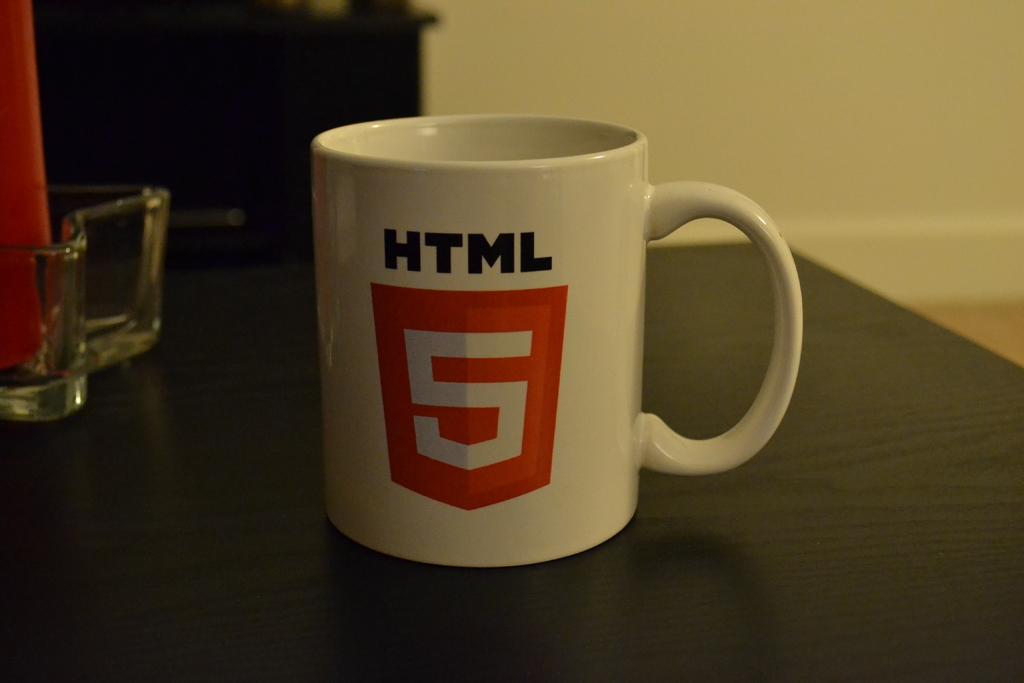Please provide a concise description of this image. In the center of the image there is a mug and a bowl placed on the table. In the background there is a wall. 